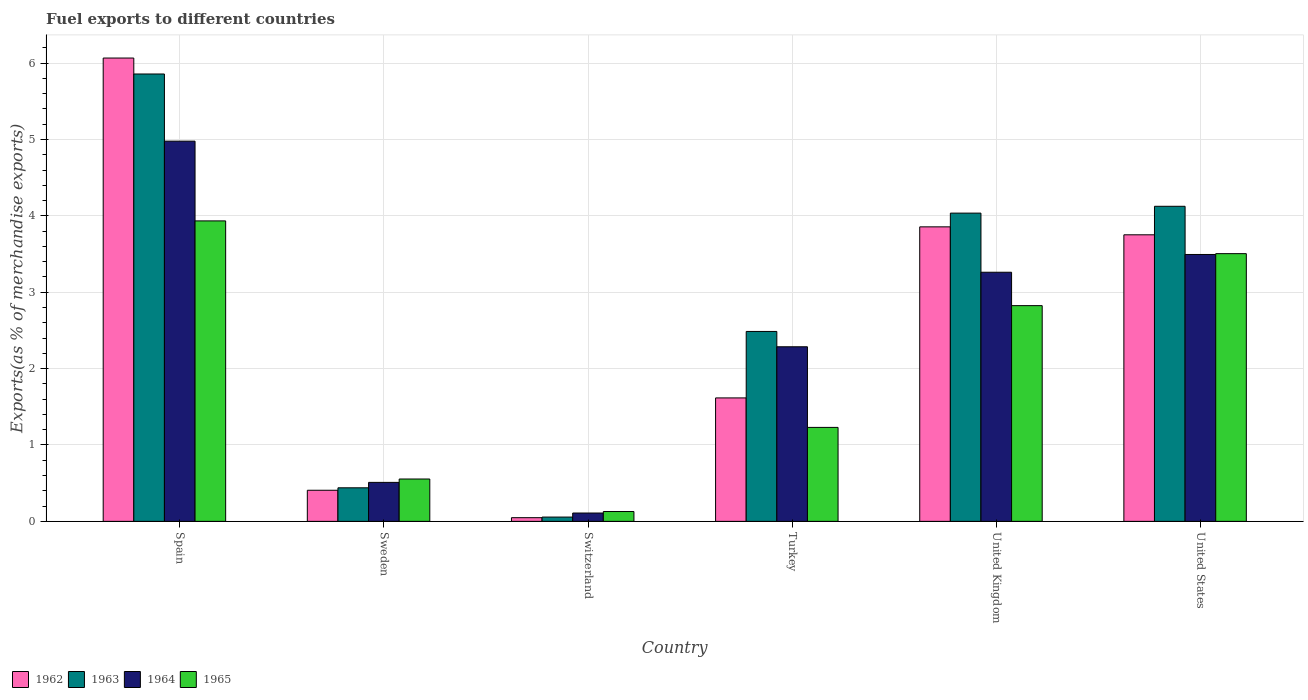How many groups of bars are there?
Provide a short and direct response. 6. What is the label of the 5th group of bars from the left?
Your response must be concise. United Kingdom. What is the percentage of exports to different countries in 1964 in Switzerland?
Provide a succinct answer. 0.11. Across all countries, what is the maximum percentage of exports to different countries in 1962?
Your answer should be very brief. 6.07. Across all countries, what is the minimum percentage of exports to different countries in 1964?
Make the answer very short. 0.11. In which country was the percentage of exports to different countries in 1962 minimum?
Your answer should be compact. Switzerland. What is the total percentage of exports to different countries in 1963 in the graph?
Make the answer very short. 17. What is the difference between the percentage of exports to different countries in 1965 in Switzerland and that in United States?
Provide a short and direct response. -3.38. What is the difference between the percentage of exports to different countries in 1965 in United States and the percentage of exports to different countries in 1962 in Switzerland?
Offer a very short reply. 3.46. What is the average percentage of exports to different countries in 1965 per country?
Your response must be concise. 2.03. What is the difference between the percentage of exports to different countries of/in 1963 and percentage of exports to different countries of/in 1962 in Sweden?
Keep it short and to the point. 0.03. What is the ratio of the percentage of exports to different countries in 1963 in Spain to that in United Kingdom?
Offer a very short reply. 1.45. Is the difference between the percentage of exports to different countries in 1963 in Spain and Sweden greater than the difference between the percentage of exports to different countries in 1962 in Spain and Sweden?
Offer a very short reply. No. What is the difference between the highest and the second highest percentage of exports to different countries in 1965?
Your answer should be compact. 0.68. What is the difference between the highest and the lowest percentage of exports to different countries in 1963?
Your answer should be compact. 5.8. In how many countries, is the percentage of exports to different countries in 1962 greater than the average percentage of exports to different countries in 1962 taken over all countries?
Ensure brevity in your answer.  3. What does the 1st bar from the right in Spain represents?
Your answer should be very brief. 1965. Are all the bars in the graph horizontal?
Offer a very short reply. No. What is the difference between two consecutive major ticks on the Y-axis?
Provide a succinct answer. 1. Does the graph contain any zero values?
Provide a succinct answer. No. Does the graph contain grids?
Ensure brevity in your answer.  Yes. What is the title of the graph?
Ensure brevity in your answer.  Fuel exports to different countries. Does "2005" appear as one of the legend labels in the graph?
Offer a very short reply. No. What is the label or title of the Y-axis?
Give a very brief answer. Exports(as % of merchandise exports). What is the Exports(as % of merchandise exports) in 1962 in Spain?
Keep it short and to the point. 6.07. What is the Exports(as % of merchandise exports) in 1963 in Spain?
Your answer should be very brief. 5.86. What is the Exports(as % of merchandise exports) of 1964 in Spain?
Your response must be concise. 4.98. What is the Exports(as % of merchandise exports) of 1965 in Spain?
Give a very brief answer. 3.93. What is the Exports(as % of merchandise exports) of 1962 in Sweden?
Provide a succinct answer. 0.41. What is the Exports(as % of merchandise exports) in 1963 in Sweden?
Your answer should be compact. 0.44. What is the Exports(as % of merchandise exports) of 1964 in Sweden?
Your response must be concise. 0.51. What is the Exports(as % of merchandise exports) in 1965 in Sweden?
Make the answer very short. 0.55. What is the Exports(as % of merchandise exports) of 1962 in Switzerland?
Your response must be concise. 0.05. What is the Exports(as % of merchandise exports) in 1963 in Switzerland?
Your response must be concise. 0.06. What is the Exports(as % of merchandise exports) of 1964 in Switzerland?
Ensure brevity in your answer.  0.11. What is the Exports(as % of merchandise exports) in 1965 in Switzerland?
Provide a short and direct response. 0.13. What is the Exports(as % of merchandise exports) of 1962 in Turkey?
Your response must be concise. 1.62. What is the Exports(as % of merchandise exports) of 1963 in Turkey?
Provide a succinct answer. 2.49. What is the Exports(as % of merchandise exports) of 1964 in Turkey?
Make the answer very short. 2.29. What is the Exports(as % of merchandise exports) in 1965 in Turkey?
Your answer should be very brief. 1.23. What is the Exports(as % of merchandise exports) of 1962 in United Kingdom?
Keep it short and to the point. 3.86. What is the Exports(as % of merchandise exports) of 1963 in United Kingdom?
Your response must be concise. 4.04. What is the Exports(as % of merchandise exports) of 1964 in United Kingdom?
Give a very brief answer. 3.26. What is the Exports(as % of merchandise exports) of 1965 in United Kingdom?
Keep it short and to the point. 2.82. What is the Exports(as % of merchandise exports) in 1962 in United States?
Give a very brief answer. 3.75. What is the Exports(as % of merchandise exports) of 1963 in United States?
Offer a terse response. 4.13. What is the Exports(as % of merchandise exports) in 1964 in United States?
Ensure brevity in your answer.  3.49. What is the Exports(as % of merchandise exports) of 1965 in United States?
Offer a very short reply. 3.51. Across all countries, what is the maximum Exports(as % of merchandise exports) of 1962?
Your answer should be compact. 6.07. Across all countries, what is the maximum Exports(as % of merchandise exports) of 1963?
Provide a short and direct response. 5.86. Across all countries, what is the maximum Exports(as % of merchandise exports) of 1964?
Keep it short and to the point. 4.98. Across all countries, what is the maximum Exports(as % of merchandise exports) in 1965?
Give a very brief answer. 3.93. Across all countries, what is the minimum Exports(as % of merchandise exports) of 1962?
Ensure brevity in your answer.  0.05. Across all countries, what is the minimum Exports(as % of merchandise exports) of 1963?
Offer a very short reply. 0.06. Across all countries, what is the minimum Exports(as % of merchandise exports) of 1964?
Make the answer very short. 0.11. Across all countries, what is the minimum Exports(as % of merchandise exports) in 1965?
Provide a short and direct response. 0.13. What is the total Exports(as % of merchandise exports) in 1962 in the graph?
Offer a very short reply. 15.75. What is the total Exports(as % of merchandise exports) of 1963 in the graph?
Make the answer very short. 17. What is the total Exports(as % of merchandise exports) of 1964 in the graph?
Keep it short and to the point. 14.64. What is the total Exports(as % of merchandise exports) in 1965 in the graph?
Offer a very short reply. 12.18. What is the difference between the Exports(as % of merchandise exports) of 1962 in Spain and that in Sweden?
Offer a very short reply. 5.66. What is the difference between the Exports(as % of merchandise exports) in 1963 in Spain and that in Sweden?
Your answer should be very brief. 5.42. What is the difference between the Exports(as % of merchandise exports) in 1964 in Spain and that in Sweden?
Make the answer very short. 4.47. What is the difference between the Exports(as % of merchandise exports) in 1965 in Spain and that in Sweden?
Your response must be concise. 3.38. What is the difference between the Exports(as % of merchandise exports) in 1962 in Spain and that in Switzerland?
Provide a succinct answer. 6.02. What is the difference between the Exports(as % of merchandise exports) in 1963 in Spain and that in Switzerland?
Make the answer very short. 5.8. What is the difference between the Exports(as % of merchandise exports) in 1964 in Spain and that in Switzerland?
Give a very brief answer. 4.87. What is the difference between the Exports(as % of merchandise exports) of 1965 in Spain and that in Switzerland?
Ensure brevity in your answer.  3.81. What is the difference between the Exports(as % of merchandise exports) of 1962 in Spain and that in Turkey?
Make the answer very short. 4.45. What is the difference between the Exports(as % of merchandise exports) of 1963 in Spain and that in Turkey?
Offer a terse response. 3.37. What is the difference between the Exports(as % of merchandise exports) of 1964 in Spain and that in Turkey?
Your response must be concise. 2.69. What is the difference between the Exports(as % of merchandise exports) in 1965 in Spain and that in Turkey?
Offer a terse response. 2.7. What is the difference between the Exports(as % of merchandise exports) of 1962 in Spain and that in United Kingdom?
Your answer should be very brief. 2.21. What is the difference between the Exports(as % of merchandise exports) of 1963 in Spain and that in United Kingdom?
Make the answer very short. 1.82. What is the difference between the Exports(as % of merchandise exports) in 1964 in Spain and that in United Kingdom?
Your answer should be compact. 1.72. What is the difference between the Exports(as % of merchandise exports) in 1965 in Spain and that in United Kingdom?
Offer a very short reply. 1.11. What is the difference between the Exports(as % of merchandise exports) of 1962 in Spain and that in United States?
Provide a short and direct response. 2.31. What is the difference between the Exports(as % of merchandise exports) in 1963 in Spain and that in United States?
Your response must be concise. 1.73. What is the difference between the Exports(as % of merchandise exports) of 1964 in Spain and that in United States?
Ensure brevity in your answer.  1.48. What is the difference between the Exports(as % of merchandise exports) in 1965 in Spain and that in United States?
Make the answer very short. 0.43. What is the difference between the Exports(as % of merchandise exports) of 1962 in Sweden and that in Switzerland?
Provide a short and direct response. 0.36. What is the difference between the Exports(as % of merchandise exports) of 1963 in Sweden and that in Switzerland?
Give a very brief answer. 0.38. What is the difference between the Exports(as % of merchandise exports) in 1964 in Sweden and that in Switzerland?
Provide a short and direct response. 0.4. What is the difference between the Exports(as % of merchandise exports) of 1965 in Sweden and that in Switzerland?
Make the answer very short. 0.43. What is the difference between the Exports(as % of merchandise exports) in 1962 in Sweden and that in Turkey?
Your answer should be compact. -1.21. What is the difference between the Exports(as % of merchandise exports) of 1963 in Sweden and that in Turkey?
Offer a very short reply. -2.05. What is the difference between the Exports(as % of merchandise exports) of 1964 in Sweden and that in Turkey?
Make the answer very short. -1.78. What is the difference between the Exports(as % of merchandise exports) of 1965 in Sweden and that in Turkey?
Make the answer very short. -0.68. What is the difference between the Exports(as % of merchandise exports) of 1962 in Sweden and that in United Kingdom?
Your answer should be compact. -3.45. What is the difference between the Exports(as % of merchandise exports) of 1963 in Sweden and that in United Kingdom?
Your answer should be compact. -3.6. What is the difference between the Exports(as % of merchandise exports) of 1964 in Sweden and that in United Kingdom?
Your response must be concise. -2.75. What is the difference between the Exports(as % of merchandise exports) in 1965 in Sweden and that in United Kingdom?
Ensure brevity in your answer.  -2.27. What is the difference between the Exports(as % of merchandise exports) in 1962 in Sweden and that in United States?
Offer a very short reply. -3.34. What is the difference between the Exports(as % of merchandise exports) of 1963 in Sweden and that in United States?
Give a very brief answer. -3.69. What is the difference between the Exports(as % of merchandise exports) in 1964 in Sweden and that in United States?
Keep it short and to the point. -2.98. What is the difference between the Exports(as % of merchandise exports) of 1965 in Sweden and that in United States?
Ensure brevity in your answer.  -2.95. What is the difference between the Exports(as % of merchandise exports) in 1962 in Switzerland and that in Turkey?
Provide a succinct answer. -1.57. What is the difference between the Exports(as % of merchandise exports) of 1963 in Switzerland and that in Turkey?
Your response must be concise. -2.43. What is the difference between the Exports(as % of merchandise exports) of 1964 in Switzerland and that in Turkey?
Ensure brevity in your answer.  -2.18. What is the difference between the Exports(as % of merchandise exports) in 1965 in Switzerland and that in Turkey?
Ensure brevity in your answer.  -1.1. What is the difference between the Exports(as % of merchandise exports) of 1962 in Switzerland and that in United Kingdom?
Your answer should be compact. -3.81. What is the difference between the Exports(as % of merchandise exports) in 1963 in Switzerland and that in United Kingdom?
Give a very brief answer. -3.98. What is the difference between the Exports(as % of merchandise exports) in 1964 in Switzerland and that in United Kingdom?
Provide a short and direct response. -3.15. What is the difference between the Exports(as % of merchandise exports) in 1965 in Switzerland and that in United Kingdom?
Your answer should be very brief. -2.7. What is the difference between the Exports(as % of merchandise exports) of 1962 in Switzerland and that in United States?
Offer a terse response. -3.7. What is the difference between the Exports(as % of merchandise exports) of 1963 in Switzerland and that in United States?
Ensure brevity in your answer.  -4.07. What is the difference between the Exports(as % of merchandise exports) in 1964 in Switzerland and that in United States?
Keep it short and to the point. -3.39. What is the difference between the Exports(as % of merchandise exports) of 1965 in Switzerland and that in United States?
Keep it short and to the point. -3.38. What is the difference between the Exports(as % of merchandise exports) in 1962 in Turkey and that in United Kingdom?
Keep it short and to the point. -2.24. What is the difference between the Exports(as % of merchandise exports) in 1963 in Turkey and that in United Kingdom?
Your answer should be very brief. -1.55. What is the difference between the Exports(as % of merchandise exports) in 1964 in Turkey and that in United Kingdom?
Your response must be concise. -0.98. What is the difference between the Exports(as % of merchandise exports) of 1965 in Turkey and that in United Kingdom?
Give a very brief answer. -1.59. What is the difference between the Exports(as % of merchandise exports) in 1962 in Turkey and that in United States?
Ensure brevity in your answer.  -2.14. What is the difference between the Exports(as % of merchandise exports) in 1963 in Turkey and that in United States?
Keep it short and to the point. -1.64. What is the difference between the Exports(as % of merchandise exports) in 1964 in Turkey and that in United States?
Your response must be concise. -1.21. What is the difference between the Exports(as % of merchandise exports) of 1965 in Turkey and that in United States?
Ensure brevity in your answer.  -2.27. What is the difference between the Exports(as % of merchandise exports) of 1962 in United Kingdom and that in United States?
Offer a very short reply. 0.1. What is the difference between the Exports(as % of merchandise exports) in 1963 in United Kingdom and that in United States?
Ensure brevity in your answer.  -0.09. What is the difference between the Exports(as % of merchandise exports) of 1964 in United Kingdom and that in United States?
Provide a succinct answer. -0.23. What is the difference between the Exports(as % of merchandise exports) of 1965 in United Kingdom and that in United States?
Keep it short and to the point. -0.68. What is the difference between the Exports(as % of merchandise exports) in 1962 in Spain and the Exports(as % of merchandise exports) in 1963 in Sweden?
Offer a very short reply. 5.63. What is the difference between the Exports(as % of merchandise exports) of 1962 in Spain and the Exports(as % of merchandise exports) of 1964 in Sweden?
Ensure brevity in your answer.  5.56. What is the difference between the Exports(as % of merchandise exports) of 1962 in Spain and the Exports(as % of merchandise exports) of 1965 in Sweden?
Your answer should be compact. 5.51. What is the difference between the Exports(as % of merchandise exports) in 1963 in Spain and the Exports(as % of merchandise exports) in 1964 in Sweden?
Make the answer very short. 5.35. What is the difference between the Exports(as % of merchandise exports) of 1963 in Spain and the Exports(as % of merchandise exports) of 1965 in Sweden?
Make the answer very short. 5.3. What is the difference between the Exports(as % of merchandise exports) of 1964 in Spain and the Exports(as % of merchandise exports) of 1965 in Sweden?
Give a very brief answer. 4.42. What is the difference between the Exports(as % of merchandise exports) of 1962 in Spain and the Exports(as % of merchandise exports) of 1963 in Switzerland?
Give a very brief answer. 6.01. What is the difference between the Exports(as % of merchandise exports) of 1962 in Spain and the Exports(as % of merchandise exports) of 1964 in Switzerland?
Keep it short and to the point. 5.96. What is the difference between the Exports(as % of merchandise exports) in 1962 in Spain and the Exports(as % of merchandise exports) in 1965 in Switzerland?
Provide a succinct answer. 5.94. What is the difference between the Exports(as % of merchandise exports) in 1963 in Spain and the Exports(as % of merchandise exports) in 1964 in Switzerland?
Offer a terse response. 5.75. What is the difference between the Exports(as % of merchandise exports) of 1963 in Spain and the Exports(as % of merchandise exports) of 1965 in Switzerland?
Provide a short and direct response. 5.73. What is the difference between the Exports(as % of merchandise exports) of 1964 in Spain and the Exports(as % of merchandise exports) of 1965 in Switzerland?
Give a very brief answer. 4.85. What is the difference between the Exports(as % of merchandise exports) in 1962 in Spain and the Exports(as % of merchandise exports) in 1963 in Turkey?
Provide a succinct answer. 3.58. What is the difference between the Exports(as % of merchandise exports) in 1962 in Spain and the Exports(as % of merchandise exports) in 1964 in Turkey?
Offer a terse response. 3.78. What is the difference between the Exports(as % of merchandise exports) in 1962 in Spain and the Exports(as % of merchandise exports) in 1965 in Turkey?
Ensure brevity in your answer.  4.84. What is the difference between the Exports(as % of merchandise exports) in 1963 in Spain and the Exports(as % of merchandise exports) in 1964 in Turkey?
Your response must be concise. 3.57. What is the difference between the Exports(as % of merchandise exports) of 1963 in Spain and the Exports(as % of merchandise exports) of 1965 in Turkey?
Keep it short and to the point. 4.63. What is the difference between the Exports(as % of merchandise exports) in 1964 in Spain and the Exports(as % of merchandise exports) in 1965 in Turkey?
Make the answer very short. 3.75. What is the difference between the Exports(as % of merchandise exports) of 1962 in Spain and the Exports(as % of merchandise exports) of 1963 in United Kingdom?
Provide a short and direct response. 2.03. What is the difference between the Exports(as % of merchandise exports) in 1962 in Spain and the Exports(as % of merchandise exports) in 1964 in United Kingdom?
Offer a very short reply. 2.8. What is the difference between the Exports(as % of merchandise exports) in 1962 in Spain and the Exports(as % of merchandise exports) in 1965 in United Kingdom?
Ensure brevity in your answer.  3.24. What is the difference between the Exports(as % of merchandise exports) in 1963 in Spain and the Exports(as % of merchandise exports) in 1964 in United Kingdom?
Provide a succinct answer. 2.6. What is the difference between the Exports(as % of merchandise exports) in 1963 in Spain and the Exports(as % of merchandise exports) in 1965 in United Kingdom?
Give a very brief answer. 3.03. What is the difference between the Exports(as % of merchandise exports) in 1964 in Spain and the Exports(as % of merchandise exports) in 1965 in United Kingdom?
Make the answer very short. 2.15. What is the difference between the Exports(as % of merchandise exports) in 1962 in Spain and the Exports(as % of merchandise exports) in 1963 in United States?
Keep it short and to the point. 1.94. What is the difference between the Exports(as % of merchandise exports) of 1962 in Spain and the Exports(as % of merchandise exports) of 1964 in United States?
Offer a very short reply. 2.57. What is the difference between the Exports(as % of merchandise exports) of 1962 in Spain and the Exports(as % of merchandise exports) of 1965 in United States?
Give a very brief answer. 2.56. What is the difference between the Exports(as % of merchandise exports) of 1963 in Spain and the Exports(as % of merchandise exports) of 1964 in United States?
Give a very brief answer. 2.36. What is the difference between the Exports(as % of merchandise exports) of 1963 in Spain and the Exports(as % of merchandise exports) of 1965 in United States?
Give a very brief answer. 2.35. What is the difference between the Exports(as % of merchandise exports) in 1964 in Spain and the Exports(as % of merchandise exports) in 1965 in United States?
Provide a short and direct response. 1.47. What is the difference between the Exports(as % of merchandise exports) in 1962 in Sweden and the Exports(as % of merchandise exports) in 1963 in Switzerland?
Keep it short and to the point. 0.35. What is the difference between the Exports(as % of merchandise exports) of 1962 in Sweden and the Exports(as % of merchandise exports) of 1964 in Switzerland?
Your answer should be very brief. 0.3. What is the difference between the Exports(as % of merchandise exports) of 1962 in Sweden and the Exports(as % of merchandise exports) of 1965 in Switzerland?
Keep it short and to the point. 0.28. What is the difference between the Exports(as % of merchandise exports) of 1963 in Sweden and the Exports(as % of merchandise exports) of 1964 in Switzerland?
Provide a short and direct response. 0.33. What is the difference between the Exports(as % of merchandise exports) of 1963 in Sweden and the Exports(as % of merchandise exports) of 1965 in Switzerland?
Your answer should be very brief. 0.31. What is the difference between the Exports(as % of merchandise exports) in 1964 in Sweden and the Exports(as % of merchandise exports) in 1965 in Switzerland?
Ensure brevity in your answer.  0.38. What is the difference between the Exports(as % of merchandise exports) of 1962 in Sweden and the Exports(as % of merchandise exports) of 1963 in Turkey?
Your response must be concise. -2.08. What is the difference between the Exports(as % of merchandise exports) in 1962 in Sweden and the Exports(as % of merchandise exports) in 1964 in Turkey?
Offer a terse response. -1.88. What is the difference between the Exports(as % of merchandise exports) in 1962 in Sweden and the Exports(as % of merchandise exports) in 1965 in Turkey?
Give a very brief answer. -0.82. What is the difference between the Exports(as % of merchandise exports) in 1963 in Sweden and the Exports(as % of merchandise exports) in 1964 in Turkey?
Your answer should be very brief. -1.85. What is the difference between the Exports(as % of merchandise exports) in 1963 in Sweden and the Exports(as % of merchandise exports) in 1965 in Turkey?
Your response must be concise. -0.79. What is the difference between the Exports(as % of merchandise exports) of 1964 in Sweden and the Exports(as % of merchandise exports) of 1965 in Turkey?
Your response must be concise. -0.72. What is the difference between the Exports(as % of merchandise exports) of 1962 in Sweden and the Exports(as % of merchandise exports) of 1963 in United Kingdom?
Provide a succinct answer. -3.63. What is the difference between the Exports(as % of merchandise exports) in 1962 in Sweden and the Exports(as % of merchandise exports) in 1964 in United Kingdom?
Your answer should be compact. -2.85. What is the difference between the Exports(as % of merchandise exports) in 1962 in Sweden and the Exports(as % of merchandise exports) in 1965 in United Kingdom?
Your answer should be compact. -2.42. What is the difference between the Exports(as % of merchandise exports) in 1963 in Sweden and the Exports(as % of merchandise exports) in 1964 in United Kingdom?
Your answer should be compact. -2.82. What is the difference between the Exports(as % of merchandise exports) in 1963 in Sweden and the Exports(as % of merchandise exports) in 1965 in United Kingdom?
Offer a very short reply. -2.38. What is the difference between the Exports(as % of merchandise exports) in 1964 in Sweden and the Exports(as % of merchandise exports) in 1965 in United Kingdom?
Provide a short and direct response. -2.31. What is the difference between the Exports(as % of merchandise exports) in 1962 in Sweden and the Exports(as % of merchandise exports) in 1963 in United States?
Keep it short and to the point. -3.72. What is the difference between the Exports(as % of merchandise exports) of 1962 in Sweden and the Exports(as % of merchandise exports) of 1964 in United States?
Give a very brief answer. -3.09. What is the difference between the Exports(as % of merchandise exports) in 1962 in Sweden and the Exports(as % of merchandise exports) in 1965 in United States?
Keep it short and to the point. -3.1. What is the difference between the Exports(as % of merchandise exports) in 1963 in Sweden and the Exports(as % of merchandise exports) in 1964 in United States?
Offer a very short reply. -3.05. What is the difference between the Exports(as % of merchandise exports) of 1963 in Sweden and the Exports(as % of merchandise exports) of 1965 in United States?
Your response must be concise. -3.07. What is the difference between the Exports(as % of merchandise exports) in 1964 in Sweden and the Exports(as % of merchandise exports) in 1965 in United States?
Give a very brief answer. -2.99. What is the difference between the Exports(as % of merchandise exports) of 1962 in Switzerland and the Exports(as % of merchandise exports) of 1963 in Turkey?
Ensure brevity in your answer.  -2.44. What is the difference between the Exports(as % of merchandise exports) of 1962 in Switzerland and the Exports(as % of merchandise exports) of 1964 in Turkey?
Your answer should be compact. -2.24. What is the difference between the Exports(as % of merchandise exports) in 1962 in Switzerland and the Exports(as % of merchandise exports) in 1965 in Turkey?
Make the answer very short. -1.18. What is the difference between the Exports(as % of merchandise exports) of 1963 in Switzerland and the Exports(as % of merchandise exports) of 1964 in Turkey?
Provide a succinct answer. -2.23. What is the difference between the Exports(as % of merchandise exports) of 1963 in Switzerland and the Exports(as % of merchandise exports) of 1965 in Turkey?
Provide a succinct answer. -1.17. What is the difference between the Exports(as % of merchandise exports) of 1964 in Switzerland and the Exports(as % of merchandise exports) of 1965 in Turkey?
Offer a terse response. -1.12. What is the difference between the Exports(as % of merchandise exports) in 1962 in Switzerland and the Exports(as % of merchandise exports) in 1963 in United Kingdom?
Make the answer very short. -3.99. What is the difference between the Exports(as % of merchandise exports) in 1962 in Switzerland and the Exports(as % of merchandise exports) in 1964 in United Kingdom?
Offer a very short reply. -3.21. What is the difference between the Exports(as % of merchandise exports) of 1962 in Switzerland and the Exports(as % of merchandise exports) of 1965 in United Kingdom?
Your answer should be compact. -2.78. What is the difference between the Exports(as % of merchandise exports) in 1963 in Switzerland and the Exports(as % of merchandise exports) in 1964 in United Kingdom?
Keep it short and to the point. -3.21. What is the difference between the Exports(as % of merchandise exports) in 1963 in Switzerland and the Exports(as % of merchandise exports) in 1965 in United Kingdom?
Give a very brief answer. -2.77. What is the difference between the Exports(as % of merchandise exports) in 1964 in Switzerland and the Exports(as % of merchandise exports) in 1965 in United Kingdom?
Your answer should be very brief. -2.72. What is the difference between the Exports(as % of merchandise exports) in 1962 in Switzerland and the Exports(as % of merchandise exports) in 1963 in United States?
Offer a terse response. -4.08. What is the difference between the Exports(as % of merchandise exports) of 1962 in Switzerland and the Exports(as % of merchandise exports) of 1964 in United States?
Offer a terse response. -3.45. What is the difference between the Exports(as % of merchandise exports) in 1962 in Switzerland and the Exports(as % of merchandise exports) in 1965 in United States?
Offer a terse response. -3.46. What is the difference between the Exports(as % of merchandise exports) of 1963 in Switzerland and the Exports(as % of merchandise exports) of 1964 in United States?
Make the answer very short. -3.44. What is the difference between the Exports(as % of merchandise exports) of 1963 in Switzerland and the Exports(as % of merchandise exports) of 1965 in United States?
Make the answer very short. -3.45. What is the difference between the Exports(as % of merchandise exports) of 1964 in Switzerland and the Exports(as % of merchandise exports) of 1965 in United States?
Make the answer very short. -3.4. What is the difference between the Exports(as % of merchandise exports) of 1962 in Turkey and the Exports(as % of merchandise exports) of 1963 in United Kingdom?
Make the answer very short. -2.42. What is the difference between the Exports(as % of merchandise exports) of 1962 in Turkey and the Exports(as % of merchandise exports) of 1964 in United Kingdom?
Offer a very short reply. -1.65. What is the difference between the Exports(as % of merchandise exports) in 1962 in Turkey and the Exports(as % of merchandise exports) in 1965 in United Kingdom?
Your answer should be compact. -1.21. What is the difference between the Exports(as % of merchandise exports) in 1963 in Turkey and the Exports(as % of merchandise exports) in 1964 in United Kingdom?
Provide a short and direct response. -0.78. What is the difference between the Exports(as % of merchandise exports) of 1963 in Turkey and the Exports(as % of merchandise exports) of 1965 in United Kingdom?
Provide a succinct answer. -0.34. What is the difference between the Exports(as % of merchandise exports) of 1964 in Turkey and the Exports(as % of merchandise exports) of 1965 in United Kingdom?
Offer a very short reply. -0.54. What is the difference between the Exports(as % of merchandise exports) in 1962 in Turkey and the Exports(as % of merchandise exports) in 1963 in United States?
Provide a short and direct response. -2.51. What is the difference between the Exports(as % of merchandise exports) in 1962 in Turkey and the Exports(as % of merchandise exports) in 1964 in United States?
Make the answer very short. -1.88. What is the difference between the Exports(as % of merchandise exports) in 1962 in Turkey and the Exports(as % of merchandise exports) in 1965 in United States?
Offer a terse response. -1.89. What is the difference between the Exports(as % of merchandise exports) in 1963 in Turkey and the Exports(as % of merchandise exports) in 1964 in United States?
Give a very brief answer. -1.01. What is the difference between the Exports(as % of merchandise exports) of 1963 in Turkey and the Exports(as % of merchandise exports) of 1965 in United States?
Keep it short and to the point. -1.02. What is the difference between the Exports(as % of merchandise exports) of 1964 in Turkey and the Exports(as % of merchandise exports) of 1965 in United States?
Your response must be concise. -1.22. What is the difference between the Exports(as % of merchandise exports) of 1962 in United Kingdom and the Exports(as % of merchandise exports) of 1963 in United States?
Make the answer very short. -0.27. What is the difference between the Exports(as % of merchandise exports) of 1962 in United Kingdom and the Exports(as % of merchandise exports) of 1964 in United States?
Make the answer very short. 0.36. What is the difference between the Exports(as % of merchandise exports) in 1962 in United Kingdom and the Exports(as % of merchandise exports) in 1965 in United States?
Ensure brevity in your answer.  0.35. What is the difference between the Exports(as % of merchandise exports) of 1963 in United Kingdom and the Exports(as % of merchandise exports) of 1964 in United States?
Ensure brevity in your answer.  0.54. What is the difference between the Exports(as % of merchandise exports) of 1963 in United Kingdom and the Exports(as % of merchandise exports) of 1965 in United States?
Your answer should be compact. 0.53. What is the difference between the Exports(as % of merchandise exports) of 1964 in United Kingdom and the Exports(as % of merchandise exports) of 1965 in United States?
Ensure brevity in your answer.  -0.24. What is the average Exports(as % of merchandise exports) in 1962 per country?
Provide a succinct answer. 2.62. What is the average Exports(as % of merchandise exports) of 1963 per country?
Provide a short and direct response. 2.83. What is the average Exports(as % of merchandise exports) in 1964 per country?
Your answer should be very brief. 2.44. What is the average Exports(as % of merchandise exports) in 1965 per country?
Ensure brevity in your answer.  2.03. What is the difference between the Exports(as % of merchandise exports) in 1962 and Exports(as % of merchandise exports) in 1963 in Spain?
Your answer should be compact. 0.21. What is the difference between the Exports(as % of merchandise exports) of 1962 and Exports(as % of merchandise exports) of 1964 in Spain?
Your answer should be very brief. 1.09. What is the difference between the Exports(as % of merchandise exports) of 1962 and Exports(as % of merchandise exports) of 1965 in Spain?
Make the answer very short. 2.13. What is the difference between the Exports(as % of merchandise exports) of 1963 and Exports(as % of merchandise exports) of 1964 in Spain?
Offer a terse response. 0.88. What is the difference between the Exports(as % of merchandise exports) in 1963 and Exports(as % of merchandise exports) in 1965 in Spain?
Offer a very short reply. 1.92. What is the difference between the Exports(as % of merchandise exports) of 1964 and Exports(as % of merchandise exports) of 1965 in Spain?
Make the answer very short. 1.04. What is the difference between the Exports(as % of merchandise exports) of 1962 and Exports(as % of merchandise exports) of 1963 in Sweden?
Provide a short and direct response. -0.03. What is the difference between the Exports(as % of merchandise exports) of 1962 and Exports(as % of merchandise exports) of 1964 in Sweden?
Your answer should be compact. -0.1. What is the difference between the Exports(as % of merchandise exports) in 1962 and Exports(as % of merchandise exports) in 1965 in Sweden?
Offer a very short reply. -0.15. What is the difference between the Exports(as % of merchandise exports) of 1963 and Exports(as % of merchandise exports) of 1964 in Sweden?
Make the answer very short. -0.07. What is the difference between the Exports(as % of merchandise exports) of 1963 and Exports(as % of merchandise exports) of 1965 in Sweden?
Your answer should be very brief. -0.12. What is the difference between the Exports(as % of merchandise exports) of 1964 and Exports(as % of merchandise exports) of 1965 in Sweden?
Your answer should be compact. -0.04. What is the difference between the Exports(as % of merchandise exports) in 1962 and Exports(as % of merchandise exports) in 1963 in Switzerland?
Your answer should be very brief. -0.01. What is the difference between the Exports(as % of merchandise exports) of 1962 and Exports(as % of merchandise exports) of 1964 in Switzerland?
Make the answer very short. -0.06. What is the difference between the Exports(as % of merchandise exports) in 1962 and Exports(as % of merchandise exports) in 1965 in Switzerland?
Keep it short and to the point. -0.08. What is the difference between the Exports(as % of merchandise exports) in 1963 and Exports(as % of merchandise exports) in 1964 in Switzerland?
Make the answer very short. -0.05. What is the difference between the Exports(as % of merchandise exports) in 1963 and Exports(as % of merchandise exports) in 1965 in Switzerland?
Keep it short and to the point. -0.07. What is the difference between the Exports(as % of merchandise exports) in 1964 and Exports(as % of merchandise exports) in 1965 in Switzerland?
Offer a very short reply. -0.02. What is the difference between the Exports(as % of merchandise exports) in 1962 and Exports(as % of merchandise exports) in 1963 in Turkey?
Ensure brevity in your answer.  -0.87. What is the difference between the Exports(as % of merchandise exports) of 1962 and Exports(as % of merchandise exports) of 1964 in Turkey?
Your response must be concise. -0.67. What is the difference between the Exports(as % of merchandise exports) in 1962 and Exports(as % of merchandise exports) in 1965 in Turkey?
Offer a very short reply. 0.39. What is the difference between the Exports(as % of merchandise exports) in 1963 and Exports(as % of merchandise exports) in 1964 in Turkey?
Offer a very short reply. 0.2. What is the difference between the Exports(as % of merchandise exports) of 1963 and Exports(as % of merchandise exports) of 1965 in Turkey?
Give a very brief answer. 1.26. What is the difference between the Exports(as % of merchandise exports) in 1964 and Exports(as % of merchandise exports) in 1965 in Turkey?
Give a very brief answer. 1.06. What is the difference between the Exports(as % of merchandise exports) of 1962 and Exports(as % of merchandise exports) of 1963 in United Kingdom?
Keep it short and to the point. -0.18. What is the difference between the Exports(as % of merchandise exports) in 1962 and Exports(as % of merchandise exports) in 1964 in United Kingdom?
Provide a succinct answer. 0.59. What is the difference between the Exports(as % of merchandise exports) of 1962 and Exports(as % of merchandise exports) of 1965 in United Kingdom?
Provide a short and direct response. 1.03. What is the difference between the Exports(as % of merchandise exports) of 1963 and Exports(as % of merchandise exports) of 1964 in United Kingdom?
Offer a very short reply. 0.77. What is the difference between the Exports(as % of merchandise exports) in 1963 and Exports(as % of merchandise exports) in 1965 in United Kingdom?
Ensure brevity in your answer.  1.21. What is the difference between the Exports(as % of merchandise exports) in 1964 and Exports(as % of merchandise exports) in 1965 in United Kingdom?
Keep it short and to the point. 0.44. What is the difference between the Exports(as % of merchandise exports) in 1962 and Exports(as % of merchandise exports) in 1963 in United States?
Offer a very short reply. -0.37. What is the difference between the Exports(as % of merchandise exports) in 1962 and Exports(as % of merchandise exports) in 1964 in United States?
Give a very brief answer. 0.26. What is the difference between the Exports(as % of merchandise exports) in 1962 and Exports(as % of merchandise exports) in 1965 in United States?
Give a very brief answer. 0.25. What is the difference between the Exports(as % of merchandise exports) in 1963 and Exports(as % of merchandise exports) in 1964 in United States?
Make the answer very short. 0.63. What is the difference between the Exports(as % of merchandise exports) of 1963 and Exports(as % of merchandise exports) of 1965 in United States?
Offer a terse response. 0.62. What is the difference between the Exports(as % of merchandise exports) of 1964 and Exports(as % of merchandise exports) of 1965 in United States?
Offer a very short reply. -0.01. What is the ratio of the Exports(as % of merchandise exports) of 1962 in Spain to that in Sweden?
Ensure brevity in your answer.  14.89. What is the ratio of the Exports(as % of merchandise exports) in 1963 in Spain to that in Sweden?
Offer a terse response. 13.33. What is the ratio of the Exports(as % of merchandise exports) in 1964 in Spain to that in Sweden?
Give a very brief answer. 9.75. What is the ratio of the Exports(as % of merchandise exports) in 1965 in Spain to that in Sweden?
Provide a short and direct response. 7.09. What is the ratio of the Exports(as % of merchandise exports) of 1962 in Spain to that in Switzerland?
Give a very brief answer. 125.74. What is the ratio of the Exports(as % of merchandise exports) of 1963 in Spain to that in Switzerland?
Your answer should be very brief. 104.12. What is the ratio of the Exports(as % of merchandise exports) of 1964 in Spain to that in Switzerland?
Your answer should be very brief. 45.62. What is the ratio of the Exports(as % of merchandise exports) in 1965 in Spain to that in Switzerland?
Give a very brief answer. 30.54. What is the ratio of the Exports(as % of merchandise exports) in 1962 in Spain to that in Turkey?
Offer a terse response. 3.75. What is the ratio of the Exports(as % of merchandise exports) in 1963 in Spain to that in Turkey?
Keep it short and to the point. 2.36. What is the ratio of the Exports(as % of merchandise exports) of 1964 in Spain to that in Turkey?
Your response must be concise. 2.18. What is the ratio of the Exports(as % of merchandise exports) in 1965 in Spain to that in Turkey?
Your response must be concise. 3.2. What is the ratio of the Exports(as % of merchandise exports) of 1962 in Spain to that in United Kingdom?
Provide a succinct answer. 1.57. What is the ratio of the Exports(as % of merchandise exports) of 1963 in Spain to that in United Kingdom?
Make the answer very short. 1.45. What is the ratio of the Exports(as % of merchandise exports) in 1964 in Spain to that in United Kingdom?
Make the answer very short. 1.53. What is the ratio of the Exports(as % of merchandise exports) of 1965 in Spain to that in United Kingdom?
Ensure brevity in your answer.  1.39. What is the ratio of the Exports(as % of merchandise exports) of 1962 in Spain to that in United States?
Provide a succinct answer. 1.62. What is the ratio of the Exports(as % of merchandise exports) in 1963 in Spain to that in United States?
Provide a succinct answer. 1.42. What is the ratio of the Exports(as % of merchandise exports) in 1964 in Spain to that in United States?
Provide a short and direct response. 1.42. What is the ratio of the Exports(as % of merchandise exports) of 1965 in Spain to that in United States?
Your answer should be very brief. 1.12. What is the ratio of the Exports(as % of merchandise exports) in 1962 in Sweden to that in Switzerland?
Your answer should be compact. 8.44. What is the ratio of the Exports(as % of merchandise exports) in 1963 in Sweden to that in Switzerland?
Your answer should be compact. 7.81. What is the ratio of the Exports(as % of merchandise exports) in 1964 in Sweden to that in Switzerland?
Your response must be concise. 4.68. What is the ratio of the Exports(as % of merchandise exports) of 1965 in Sweden to that in Switzerland?
Your answer should be very brief. 4.31. What is the ratio of the Exports(as % of merchandise exports) of 1962 in Sweden to that in Turkey?
Offer a very short reply. 0.25. What is the ratio of the Exports(as % of merchandise exports) in 1963 in Sweden to that in Turkey?
Ensure brevity in your answer.  0.18. What is the ratio of the Exports(as % of merchandise exports) in 1964 in Sweden to that in Turkey?
Keep it short and to the point. 0.22. What is the ratio of the Exports(as % of merchandise exports) of 1965 in Sweden to that in Turkey?
Provide a succinct answer. 0.45. What is the ratio of the Exports(as % of merchandise exports) in 1962 in Sweden to that in United Kingdom?
Your response must be concise. 0.11. What is the ratio of the Exports(as % of merchandise exports) of 1963 in Sweden to that in United Kingdom?
Offer a very short reply. 0.11. What is the ratio of the Exports(as % of merchandise exports) in 1964 in Sweden to that in United Kingdom?
Give a very brief answer. 0.16. What is the ratio of the Exports(as % of merchandise exports) of 1965 in Sweden to that in United Kingdom?
Offer a terse response. 0.2. What is the ratio of the Exports(as % of merchandise exports) of 1962 in Sweden to that in United States?
Your answer should be very brief. 0.11. What is the ratio of the Exports(as % of merchandise exports) of 1963 in Sweden to that in United States?
Your answer should be very brief. 0.11. What is the ratio of the Exports(as % of merchandise exports) of 1964 in Sweden to that in United States?
Offer a very short reply. 0.15. What is the ratio of the Exports(as % of merchandise exports) of 1965 in Sweden to that in United States?
Keep it short and to the point. 0.16. What is the ratio of the Exports(as % of merchandise exports) in 1962 in Switzerland to that in Turkey?
Offer a very short reply. 0.03. What is the ratio of the Exports(as % of merchandise exports) in 1963 in Switzerland to that in Turkey?
Offer a very short reply. 0.02. What is the ratio of the Exports(as % of merchandise exports) in 1964 in Switzerland to that in Turkey?
Offer a very short reply. 0.05. What is the ratio of the Exports(as % of merchandise exports) of 1965 in Switzerland to that in Turkey?
Offer a very short reply. 0.1. What is the ratio of the Exports(as % of merchandise exports) of 1962 in Switzerland to that in United Kingdom?
Offer a terse response. 0.01. What is the ratio of the Exports(as % of merchandise exports) in 1963 in Switzerland to that in United Kingdom?
Provide a short and direct response. 0.01. What is the ratio of the Exports(as % of merchandise exports) in 1964 in Switzerland to that in United Kingdom?
Your answer should be compact. 0.03. What is the ratio of the Exports(as % of merchandise exports) of 1965 in Switzerland to that in United Kingdom?
Ensure brevity in your answer.  0.05. What is the ratio of the Exports(as % of merchandise exports) in 1962 in Switzerland to that in United States?
Your response must be concise. 0.01. What is the ratio of the Exports(as % of merchandise exports) of 1963 in Switzerland to that in United States?
Your response must be concise. 0.01. What is the ratio of the Exports(as % of merchandise exports) in 1964 in Switzerland to that in United States?
Keep it short and to the point. 0.03. What is the ratio of the Exports(as % of merchandise exports) in 1965 in Switzerland to that in United States?
Offer a very short reply. 0.04. What is the ratio of the Exports(as % of merchandise exports) of 1962 in Turkey to that in United Kingdom?
Offer a very short reply. 0.42. What is the ratio of the Exports(as % of merchandise exports) of 1963 in Turkey to that in United Kingdom?
Provide a short and direct response. 0.62. What is the ratio of the Exports(as % of merchandise exports) in 1964 in Turkey to that in United Kingdom?
Keep it short and to the point. 0.7. What is the ratio of the Exports(as % of merchandise exports) of 1965 in Turkey to that in United Kingdom?
Ensure brevity in your answer.  0.44. What is the ratio of the Exports(as % of merchandise exports) of 1962 in Turkey to that in United States?
Your answer should be very brief. 0.43. What is the ratio of the Exports(as % of merchandise exports) of 1963 in Turkey to that in United States?
Provide a short and direct response. 0.6. What is the ratio of the Exports(as % of merchandise exports) of 1964 in Turkey to that in United States?
Your answer should be compact. 0.65. What is the ratio of the Exports(as % of merchandise exports) of 1965 in Turkey to that in United States?
Your response must be concise. 0.35. What is the ratio of the Exports(as % of merchandise exports) of 1962 in United Kingdom to that in United States?
Your answer should be compact. 1.03. What is the ratio of the Exports(as % of merchandise exports) of 1963 in United Kingdom to that in United States?
Your answer should be very brief. 0.98. What is the ratio of the Exports(as % of merchandise exports) in 1964 in United Kingdom to that in United States?
Offer a very short reply. 0.93. What is the ratio of the Exports(as % of merchandise exports) in 1965 in United Kingdom to that in United States?
Ensure brevity in your answer.  0.81. What is the difference between the highest and the second highest Exports(as % of merchandise exports) of 1962?
Keep it short and to the point. 2.21. What is the difference between the highest and the second highest Exports(as % of merchandise exports) in 1963?
Offer a very short reply. 1.73. What is the difference between the highest and the second highest Exports(as % of merchandise exports) of 1964?
Keep it short and to the point. 1.48. What is the difference between the highest and the second highest Exports(as % of merchandise exports) in 1965?
Ensure brevity in your answer.  0.43. What is the difference between the highest and the lowest Exports(as % of merchandise exports) in 1962?
Your answer should be compact. 6.02. What is the difference between the highest and the lowest Exports(as % of merchandise exports) in 1963?
Offer a terse response. 5.8. What is the difference between the highest and the lowest Exports(as % of merchandise exports) in 1964?
Provide a succinct answer. 4.87. What is the difference between the highest and the lowest Exports(as % of merchandise exports) in 1965?
Offer a very short reply. 3.81. 